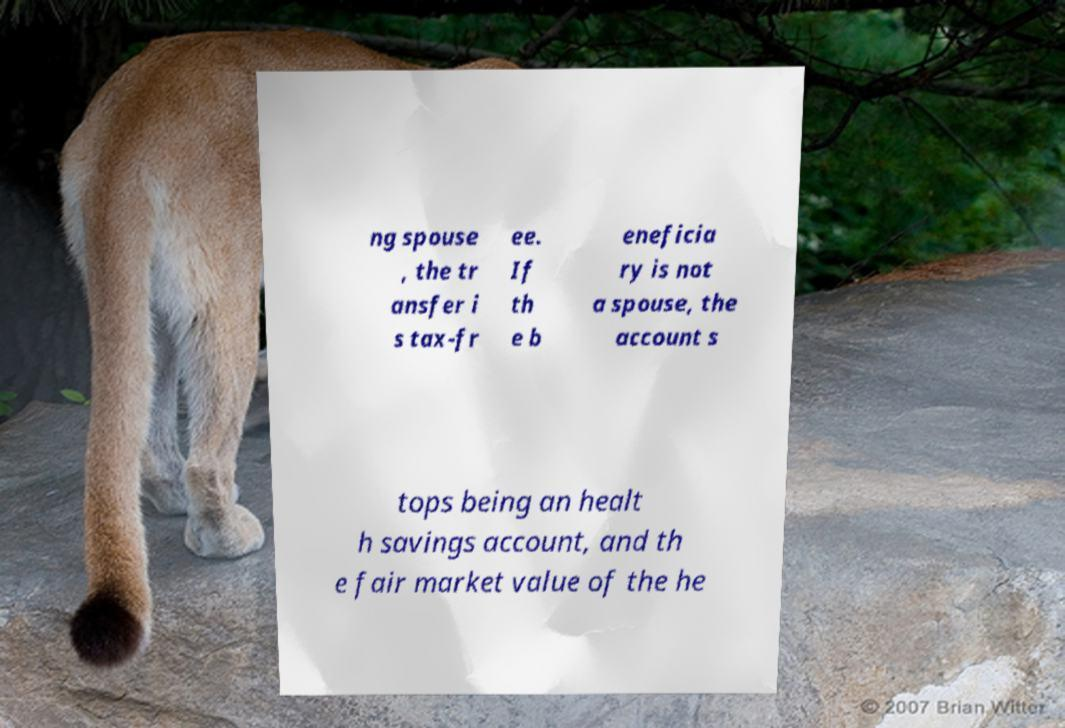Please identify and transcribe the text found in this image. ng spouse , the tr ansfer i s tax-fr ee. If th e b eneficia ry is not a spouse, the account s tops being an healt h savings account, and th e fair market value of the he 